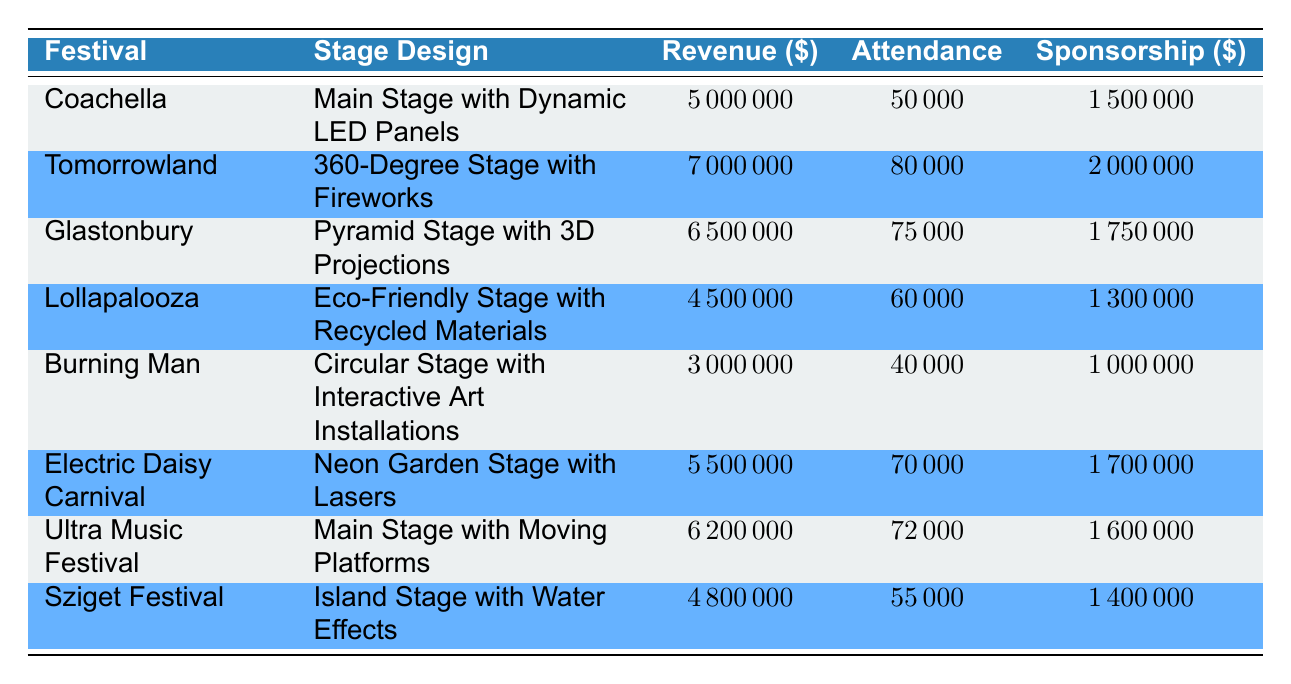What was the revenue generated by Tomorrowland? Tomorrowland's revenue can be found directly in the table under the "Revenue" column for that festival. It shows a value of 7000000 USD.
Answer: 7000000 USD Which festival had the highest attendance? To determine the highest attendance, we compare the "Attendance" values for each festival. Tomorrowland has the highest attendance at 80000.
Answer: Tomorrowland What is the total revenue generated by the festivals using eco-friendly stage designs? We identify eco-friendly stage designs: Lollapalooza (4500000) and Burning Man (3000000). Adding these values gives 4500000 + 3000000 = 7500000 USD.
Answer: 7500000 USD Did the Pyramid stage generate more revenue than the Circular stage? Looking at the revenue values, the Pyramid Stage at Glastonbury generated 6500000 USD and the Circular Stage at Burning Man generated 3000000 USD. Since 6500000 is greater than 3000000, the answer is yes.
Answer: Yes What is the average sponsorship revenue for all festivals? We sum the sponsorship revenues: 1500000 + 2000000 + 1750000 + 1300000 + 1000000 + 1700000 + 1600000 + 1400000 = 11800000 USD. There are 8 festivals, so the average is 11800000 / 8 = 1475000 USD.
Answer: 1475000 USD Which stage design had the least generated revenue? By examining the revenue columns, we see that the Circular Stage at Burning Man generated the least revenue, which is 3000000 USD.
Answer: Circular Stage with Interactive Art Installations What is the revenue difference between the 360-Degree Stage and the Neon Garden Stage? The revenue for the 360-Degree Stage at Tomorrowland is 7000000 USD, and for the Neon Garden Stage at Electric Daisy Carnival, it is 5500000 USD. The difference is 7000000 - 5500000 = 1500000 USD.
Answer: 1500000 USD Did the average attendance exceed 60000 for all festivals? Summing the attendance figures: 50000 + 80000 + 75000 + 60000 + 40000 + 70000 + 72000 + 55000 = 450000. There are 8 festivals, so the average attendance is 450000 / 8 = 56250. Since 56250 does not exceed 60000, the answer is no.
Answer: No 